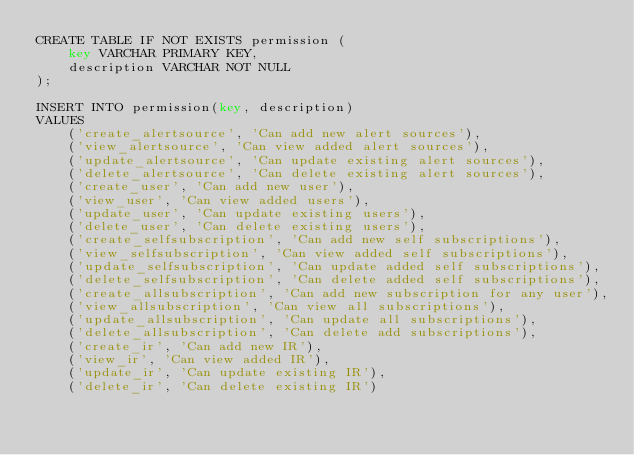<code> <loc_0><loc_0><loc_500><loc_500><_SQL_>CREATE TABLE IF NOT EXISTS permission (
    key VARCHAR PRIMARY KEY,
    description VARCHAR NOT NULL
);

INSERT INTO permission(key, description)
VALUES
    ('create_alertsource', 'Can add new alert sources'),
    ('view_alertsource', 'Can view added alert sources'),
    ('update_alertsource', 'Can update existing alert sources'),
    ('delete_alertsource', 'Can delete existing alert sources'),
    ('create_user', 'Can add new user'),
    ('view_user', 'Can view added users'),
    ('update_user', 'Can update existing users'),
    ('delete_user', 'Can delete existing users'),
    ('create_selfsubscription', 'Can add new self subscriptions'),
    ('view_selfsubscription', 'Can view added self subscriptions'),
    ('update_selfsubscription', 'Can update added self subscriptions'),
    ('delete_selfsubscription', 'Can delete added self subscriptions'),
    ('create_allsubscription', 'Can add new subscription for any user'),
    ('view_allsubscription', 'Can view all subscriptions'),
    ('update_allsubscription', 'Can update all subscriptions'),
    ('delete_allsubscription', 'Can delete add subscriptions'),
    ('create_ir', 'Can add new IR'),
    ('view_ir', 'Can view added IR'),
    ('update_ir', 'Can update existing IR'),
    ('delete_ir', 'Can delete existing IR')
    
</code> 